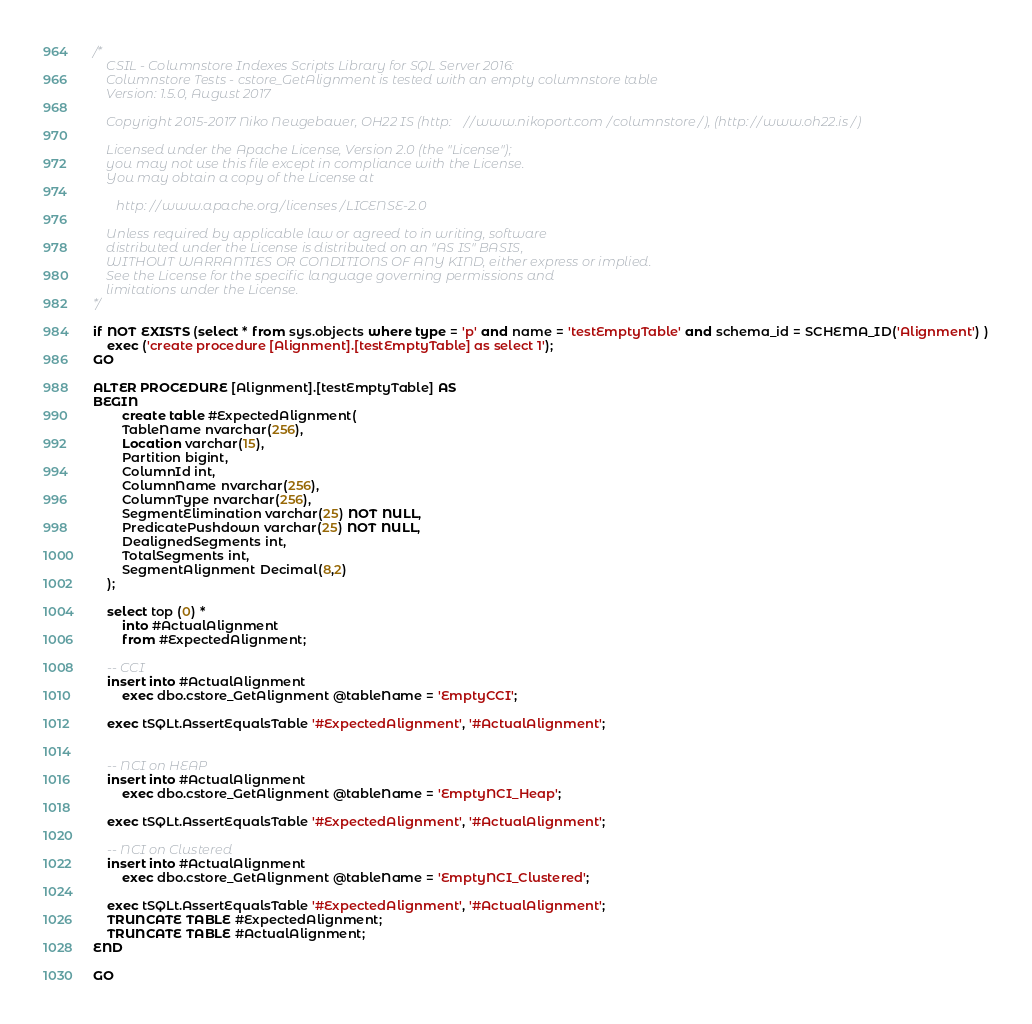<code> <loc_0><loc_0><loc_500><loc_500><_SQL_>/*
	CSIL - Columnstore Indexes Scripts Library for SQL Server 2016: 
	Columnstore Tests - cstore_GetAlignment is tested with an empty columnstore table 
	Version: 1.5.0, August 2017

	Copyright 2015-2017 Niko Neugebauer, OH22 IS (http://www.nikoport.com/columnstore/), (http://www.oh22.is/)

	Licensed under the Apache License, Version 2.0 (the "License");
	you may not use this file except in compliance with the License.
	You may obtain a copy of the License at

       http://www.apache.org/licenses/LICENSE-2.0

    Unless required by applicable law or agreed to in writing, software
    distributed under the License is distributed on an "AS IS" BASIS,
    WITHOUT WARRANTIES OR CONDITIONS OF ANY KIND, either express or implied.
    See the License for the specific language governing permissions and
    limitations under the License.
*/

if NOT EXISTS (select * from sys.objects where type = 'p' and name = 'testEmptyTable' and schema_id = SCHEMA_ID('Alignment') )
	exec ('create procedure [Alignment].[testEmptyTable] as select 1');
GO

ALTER PROCEDURE [Alignment].[testEmptyTable] AS
BEGIN
		create table #ExpectedAlignment(
		TableName nvarchar(256),
		Location varchar(15),
		Partition bigint,
		ColumnId int,
		ColumnName nvarchar(256),
		ColumnType nvarchar(256),
		SegmentElimination varchar(25) NOT NULL,
		PredicatePushdown varchar(25) NOT NULL,		
		DealignedSegments int,
		TotalSegments int,
		SegmentAlignment Decimal(8,2)
	);

	select top (0) *
		into #ActualAlignment
		from #ExpectedAlignment;

	-- CCI
	insert into #ActualAlignment 
		exec dbo.cstore_GetAlignment @tableName = 'EmptyCCI';

	exec tSQLt.AssertEqualsTable '#ExpectedAlignment', '#ActualAlignment';


	-- NCI on HEAP
	insert into #ActualAlignment 
		exec dbo.cstore_GetAlignment @tableName = 'EmptyNCI_Heap';

	exec tSQLt.AssertEqualsTable '#ExpectedAlignment', '#ActualAlignment';

	-- NCI on Clustered
	insert into #ActualAlignment 
		exec dbo.cstore_GetAlignment @tableName = 'EmptyNCI_Clustered';

	exec tSQLt.AssertEqualsTable '#ExpectedAlignment', '#ActualAlignment';
	TRUNCATE TABLE #ExpectedAlignment;
	TRUNCATE TABLE #ActualAlignment;
END

GO
</code> 